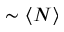Convert formula to latex. <formula><loc_0><loc_0><loc_500><loc_500>\sim \langle N \rangle</formula> 